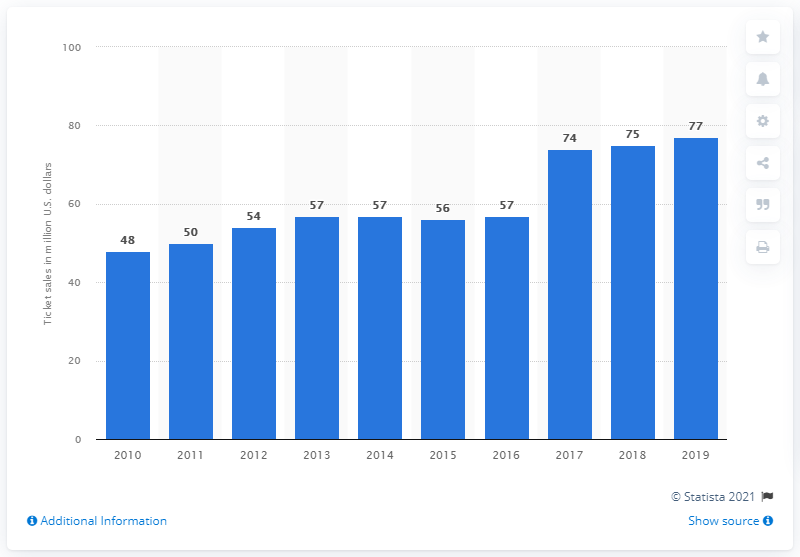Draw attention to some important aspects in this diagram. In 2019, the Atlanta Falcons generated $77 million in revenue from gate receipts. 